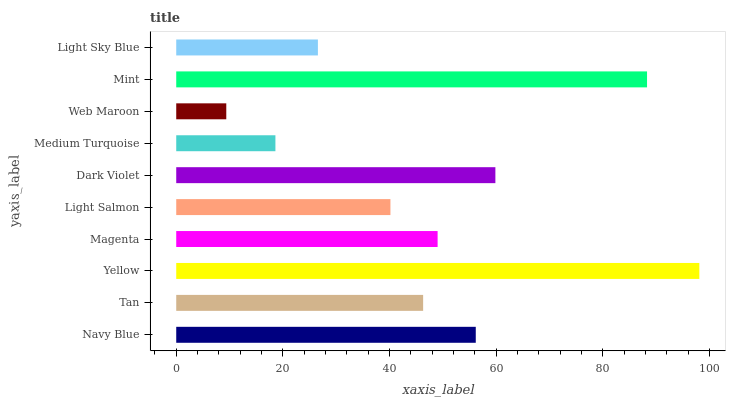Is Web Maroon the minimum?
Answer yes or no. Yes. Is Yellow the maximum?
Answer yes or no. Yes. Is Tan the minimum?
Answer yes or no. No. Is Tan the maximum?
Answer yes or no. No. Is Navy Blue greater than Tan?
Answer yes or no. Yes. Is Tan less than Navy Blue?
Answer yes or no. Yes. Is Tan greater than Navy Blue?
Answer yes or no. No. Is Navy Blue less than Tan?
Answer yes or no. No. Is Magenta the high median?
Answer yes or no. Yes. Is Tan the low median?
Answer yes or no. Yes. Is Tan the high median?
Answer yes or no. No. Is Light Salmon the low median?
Answer yes or no. No. 